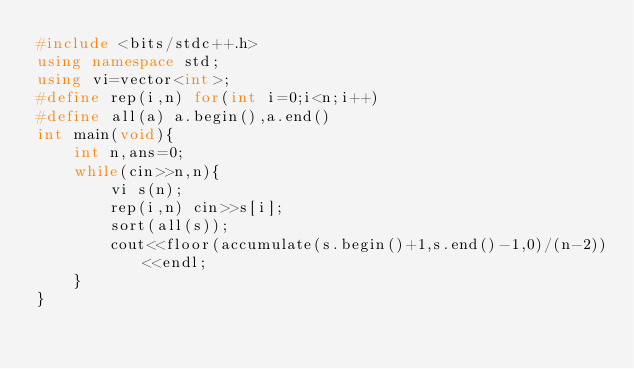Convert code to text. <code><loc_0><loc_0><loc_500><loc_500><_C++_>#include <bits/stdc++.h>
using namespace std;
using vi=vector<int>;
#define rep(i,n) for(int i=0;i<n;i++)
#define all(a) a.begin(),a.end()
int main(void){
    int n,ans=0;
    while(cin>>n,n){
        vi s(n);
        rep(i,n) cin>>s[i];
        sort(all(s));
        cout<<floor(accumulate(s.begin()+1,s.end()-1,0)/(n-2))<<endl;
    }
}</code> 